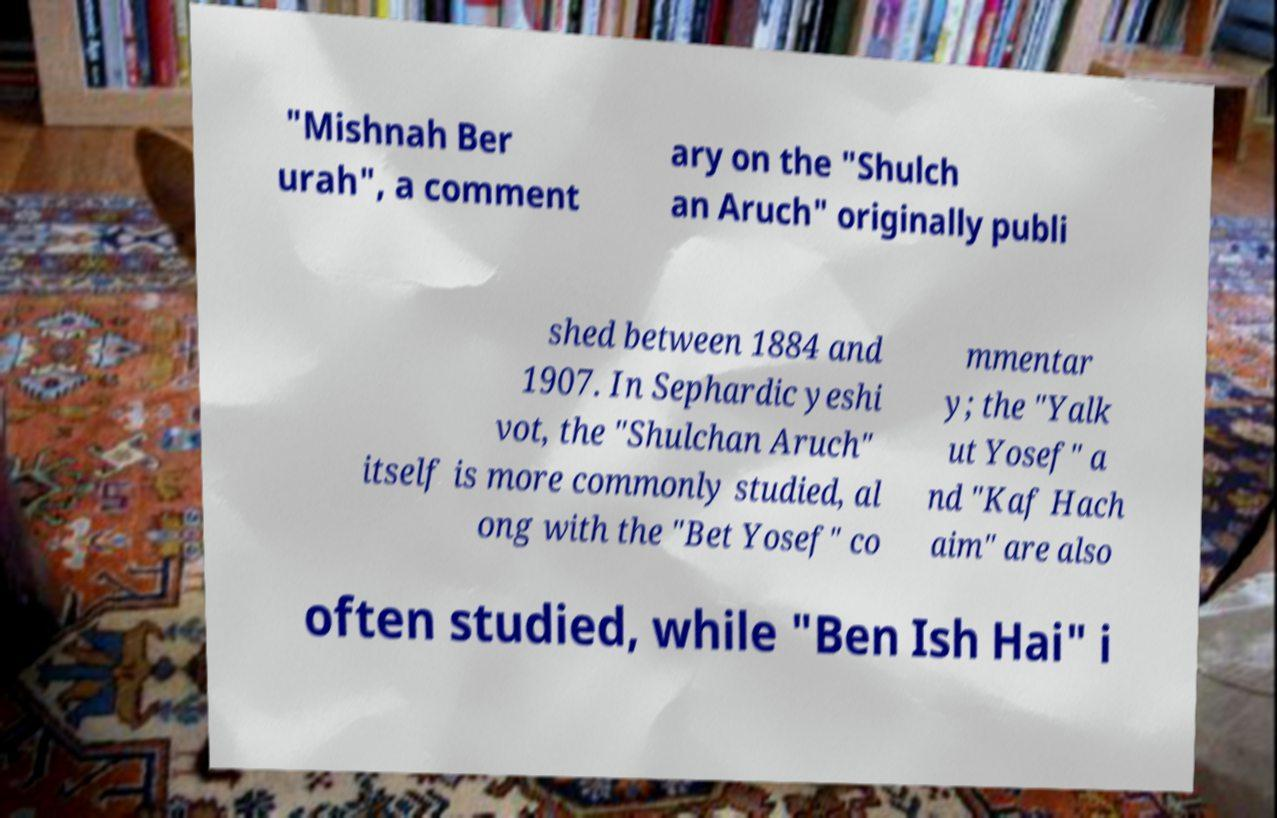I need the written content from this picture converted into text. Can you do that? "Mishnah Ber urah", a comment ary on the "Shulch an Aruch" originally publi shed between 1884 and 1907. In Sephardic yeshi vot, the "Shulchan Aruch" itself is more commonly studied, al ong with the "Bet Yosef" co mmentar y; the "Yalk ut Yosef" a nd "Kaf Hach aim" are also often studied, while "Ben Ish Hai" i 